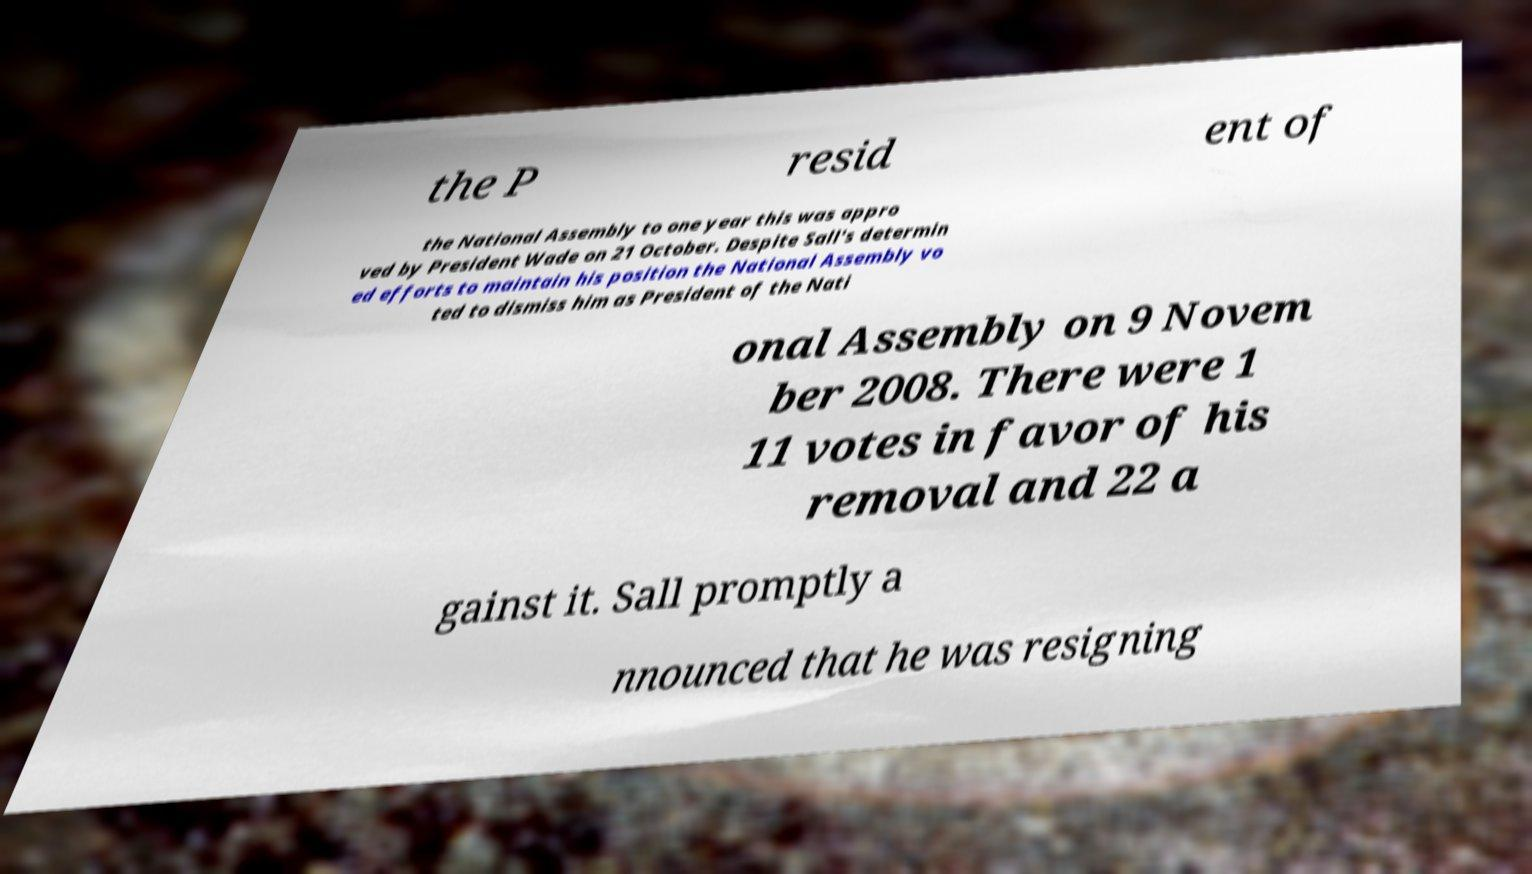What messages or text are displayed in this image? I need them in a readable, typed format. the P resid ent of the National Assembly to one year this was appro ved by President Wade on 21 October. Despite Sall's determin ed efforts to maintain his position the National Assembly vo ted to dismiss him as President of the Nati onal Assembly on 9 Novem ber 2008. There were 1 11 votes in favor of his removal and 22 a gainst it. Sall promptly a nnounced that he was resigning 